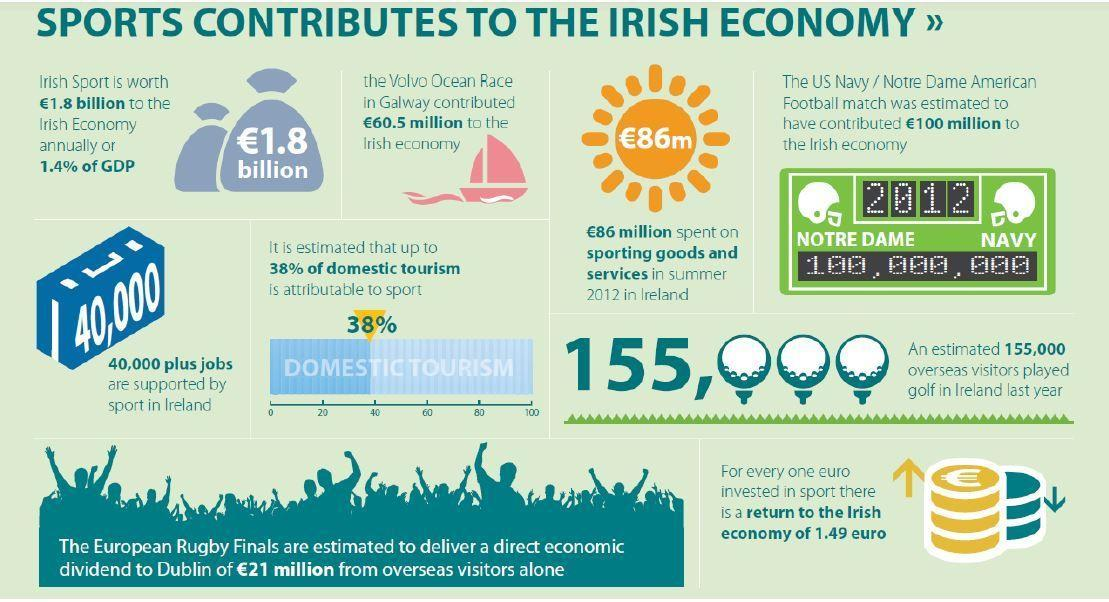What percent of domestic tourism is not attributable to sport?
Answer the question with a short phrase. 62% When was the US Navy/Notre Dame American Football match held? 2012 